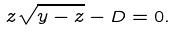Convert formula to latex. <formula><loc_0><loc_0><loc_500><loc_500>z \sqrt { y - z } - D = 0 .</formula> 